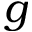Convert formula to latex. <formula><loc_0><loc_0><loc_500><loc_500>g</formula> 